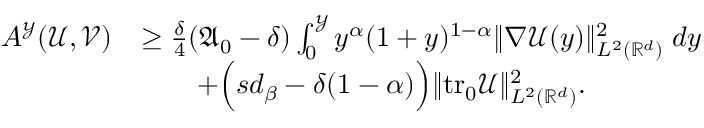<formula> <loc_0><loc_0><loc_500><loc_500>\begin{array} { r l } { A ^ { \mathcal { Y } } ( \mathcal { U } , \mathcal { V } ) } & { \geq \frac { \delta } { 4 } ( \mathfrak { A } _ { 0 } - \delta ) \int _ { 0 } ^ { \mathcal { Y } } { y ^ { \alpha } ( 1 + y ) ^ { 1 - \alpha } \| \nabla \mathcal { U } ( y ) \| _ { L ^ { 2 } ( \mathbb { R } ^ { d } ) } ^ { 2 } \, d y } } \\ & { \quad + \left ( s d _ { \beta } - \delta ( 1 - \alpha ) \right ) \| t r _ { 0 } \mathcal { U } \| _ { L ^ { 2 } ( \mathbb { R } ^ { d } ) } ^ { 2 } . } \end{array}</formula> 